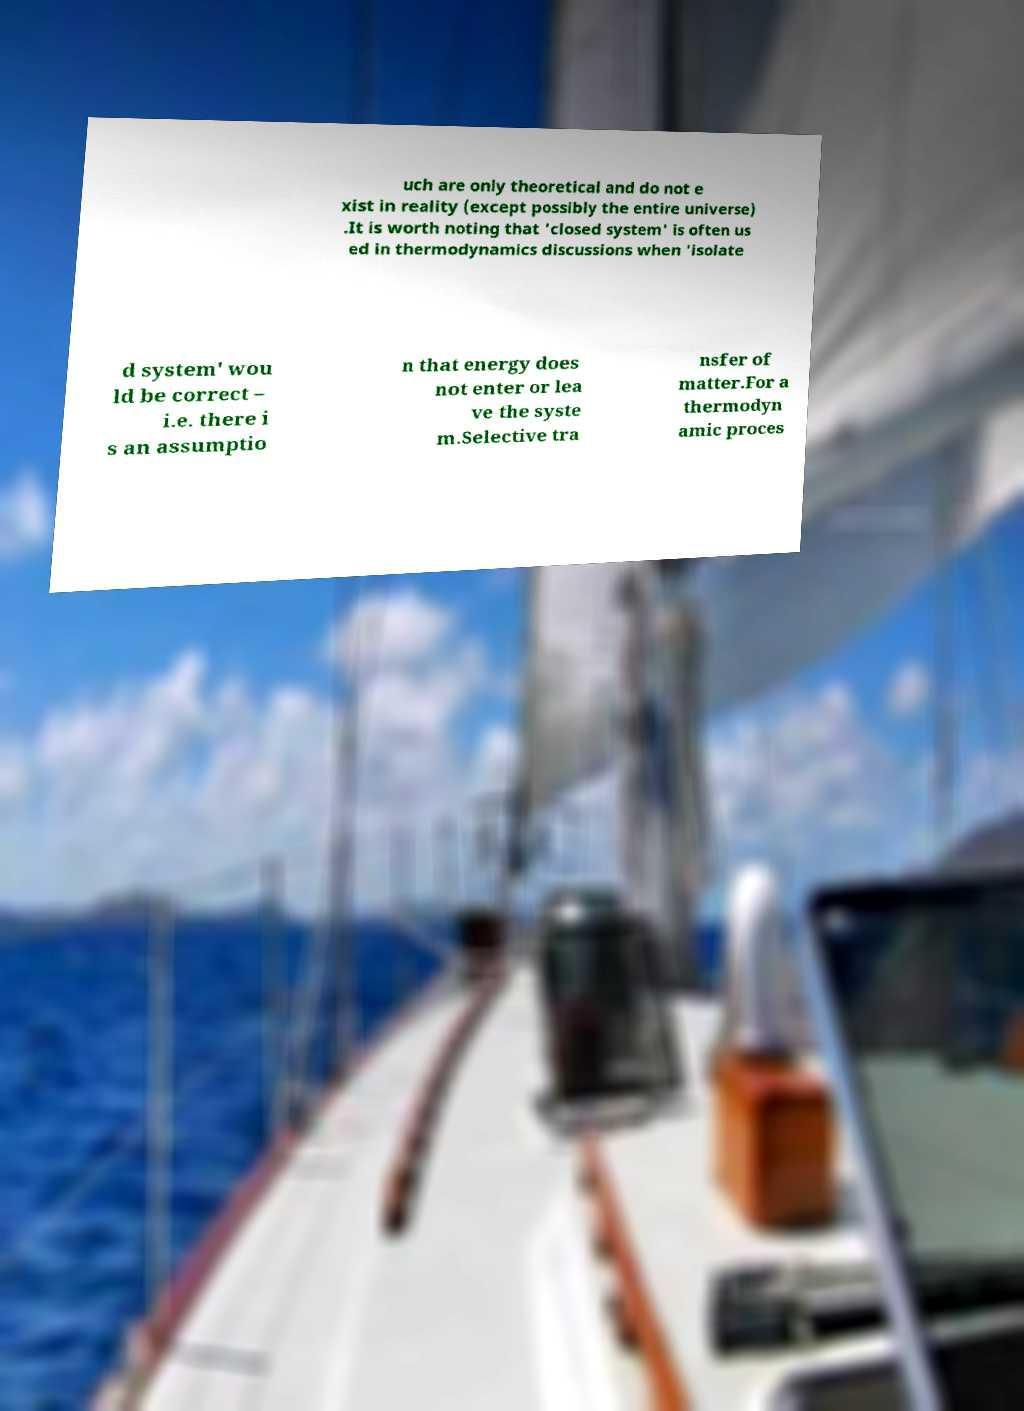Can you read and provide the text displayed in the image?This photo seems to have some interesting text. Can you extract and type it out for me? uch are only theoretical and do not e xist in reality (except possibly the entire universe) .It is worth noting that 'closed system' is often us ed in thermodynamics discussions when 'isolate d system' wou ld be correct – i.e. there i s an assumptio n that energy does not enter or lea ve the syste m.Selective tra nsfer of matter.For a thermodyn amic proces 